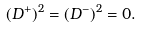Convert formula to latex. <formula><loc_0><loc_0><loc_500><loc_500>( D ^ { + } ) ^ { 2 } = ( D ^ { - } ) ^ { 2 } = 0 .</formula> 